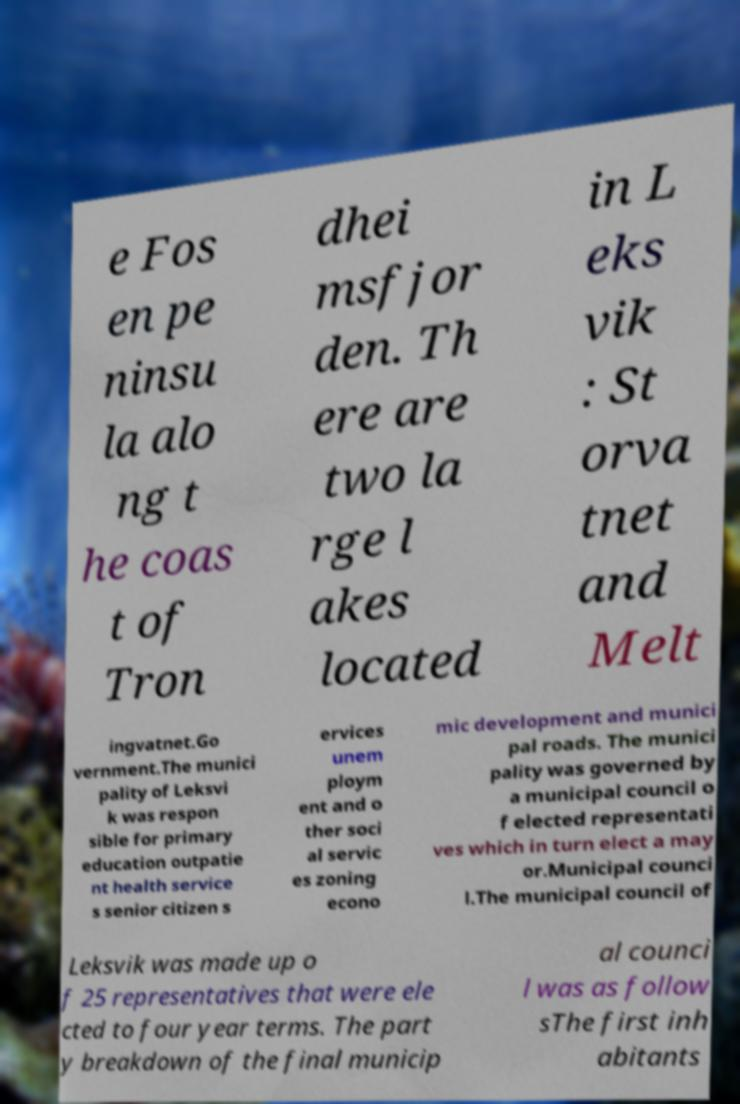I need the written content from this picture converted into text. Can you do that? e Fos en pe ninsu la alo ng t he coas t of Tron dhei msfjor den. Th ere are two la rge l akes located in L eks vik : St orva tnet and Melt ingvatnet.Go vernment.The munici pality of Leksvi k was respon sible for primary education outpatie nt health service s senior citizen s ervices unem ploym ent and o ther soci al servic es zoning econo mic development and munici pal roads. The munici pality was governed by a municipal council o f elected representati ves which in turn elect a may or.Municipal counci l.The municipal council of Leksvik was made up o f 25 representatives that were ele cted to four year terms. The part y breakdown of the final municip al counci l was as follow sThe first inh abitants 